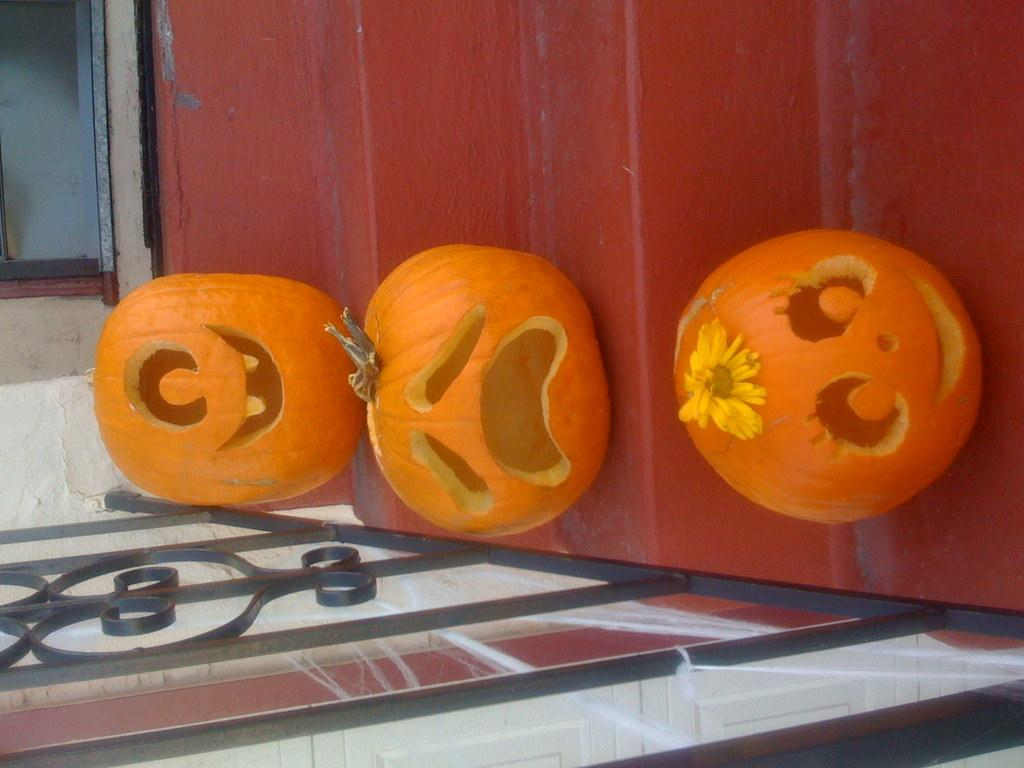What type of objects are featured in the image? There are pumpkins in the image. How are the pumpkins shaped? The pumpkins are in the shape of human smiles. Where are the pumpkins arranged? The pumpkins are arranged on a staircase. What is located at the bottom of the staircase? There is an iron grill at the bottom of the staircase. How many beds can be seen in the image? There are no beds present in the image; it features pumpkins arranged on a staircase. What type of ball is being used in the image? There is no ball present in the image. 